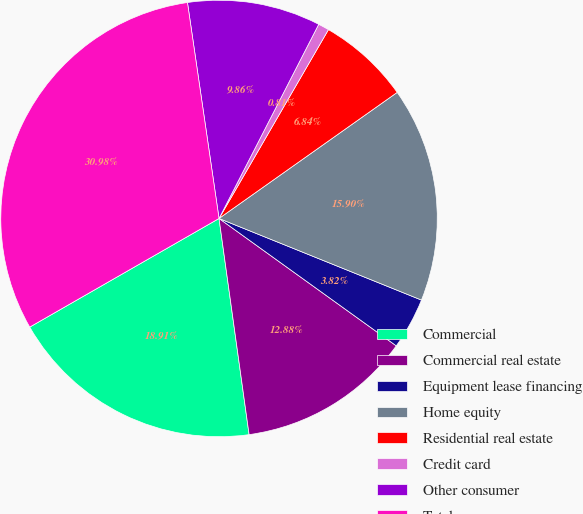Convert chart. <chart><loc_0><loc_0><loc_500><loc_500><pie_chart><fcel>Commercial<fcel>Commercial real estate<fcel>Equipment lease financing<fcel>Home equity<fcel>Residential real estate<fcel>Credit card<fcel>Other consumer<fcel>Total<nl><fcel>18.91%<fcel>12.88%<fcel>3.82%<fcel>15.9%<fcel>6.84%<fcel>0.81%<fcel>9.86%<fcel>30.98%<nl></chart> 